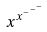<formula> <loc_0><loc_0><loc_500><loc_500>x ^ { x ^ { - ^ { - ^ { - } } } }</formula> 